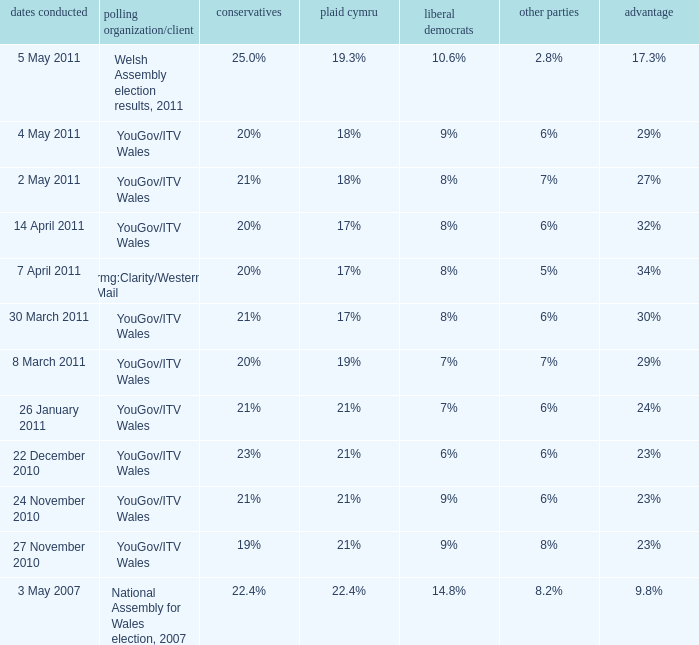Tell me the dates conducted for plaid cymru of 19% 8 March 2011. 